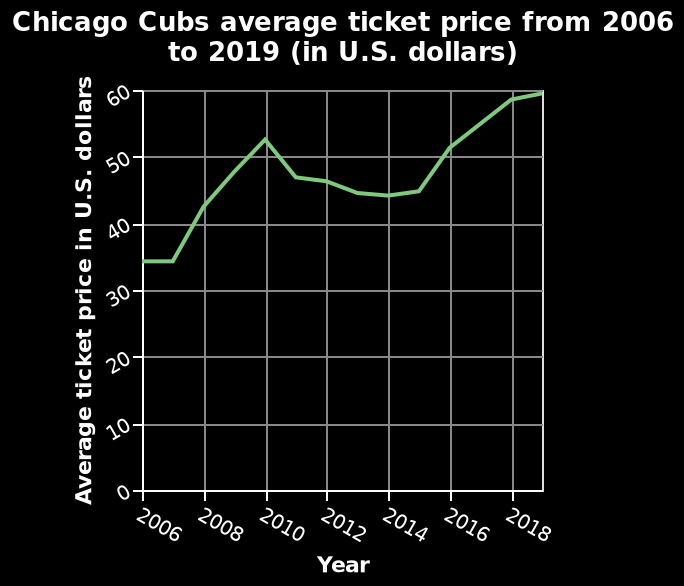<image>
In which city is the team associated with the labeled line diagram located? The team associated with the labeled line diagram is located in Chicago. Which year is the most recent one shown on the x-axis? The most recent year shown on the x-axis is 2018. 